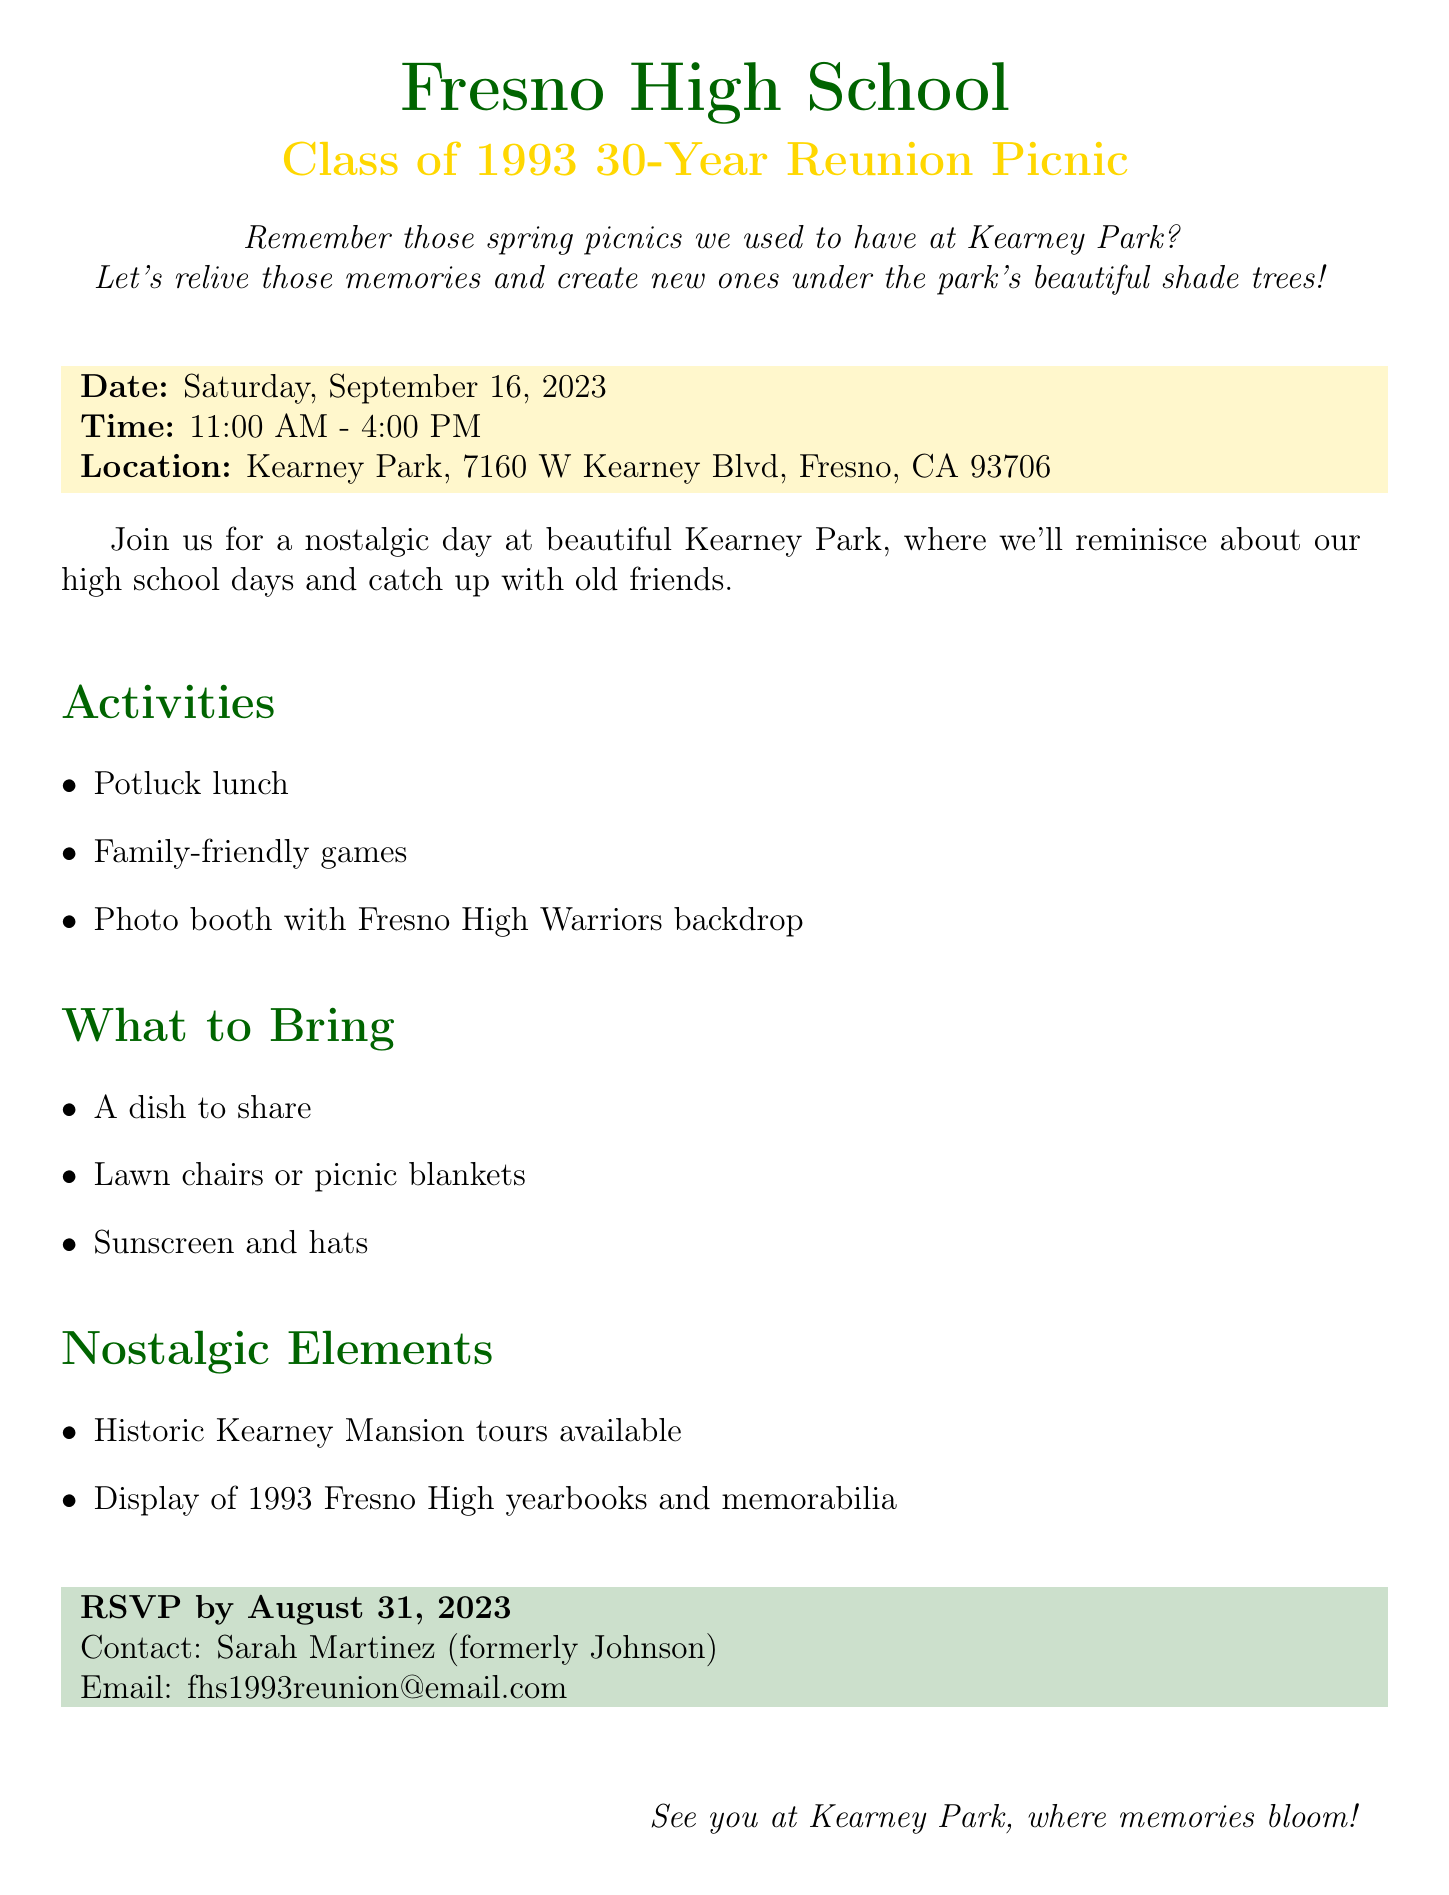What is the event name? The event name is explicitly stated in the document as the title for the reunion picnic.
Answer: Fresno High School Class of 1993 30-Year Reunion Picnic What is the date of the picnic? The date is clearly indicated in the document under the event details.
Answer: Saturday, September 16, 2023 What time does the picnic start? The starting time is mentioned in the document, providing specifics for attendees.
Answer: 11:00 AM Where is the location of the event? The location is clearly labeled in the document for easy reference.
Answer: Kearney Park, 7160 W Kearney Blvd, Fresno, CA 93706 What is one activity planned for the reunion? Activities are listed in the document, giving details of what attendees can expect.
Answer: Potluck lunch What should attendees bring? The document outlines the items attendees need to bring for the picnic.
Answer: A dish to share Who should be contacted for RSVP? The contact information for RSVP is explicitly provided in the document.
Answer: Sarah Martinez (formerly Johnson) What is the RSVP deadline? The deadline for RSVPs is clearly stated in the document, providing essential information for attendees.
Answer: August 31, 2023 What nostalgic element will be available at the picnic? Nostalgic elements are described in the document, giving a sense of history related to the event.
Answer: Historic Kearney Mansion tours available 